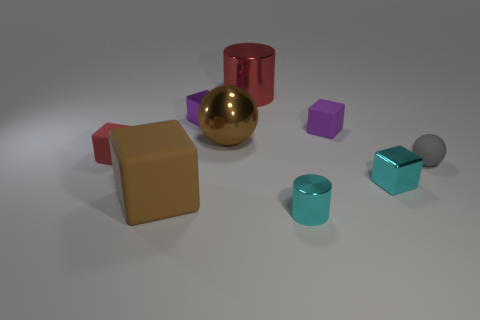There is a metal thing that is the same color as the big cube; what shape is it?
Ensure brevity in your answer.  Sphere. There is a purple rubber cube; does it have the same size as the cylinder behind the big brown shiny ball?
Offer a very short reply. No. There is a brown thing on the right side of the large rubber block; what material is it?
Provide a short and direct response. Metal. There is a tiny cyan thing that is in front of the cyan shiny block; what number of cyan metallic things are behind it?
Provide a succinct answer. 1. Are there any other small rubber objects of the same shape as the gray matte thing?
Give a very brief answer. No. Does the brown object that is right of the tiny purple metallic cube have the same size as the purple rubber object right of the big brown rubber thing?
Ensure brevity in your answer.  No. There is a brown object behind the metal cube that is in front of the tiny purple shiny thing; what is its shape?
Offer a very short reply. Sphere. What number of purple metallic objects are the same size as the red cylinder?
Your answer should be compact. 0. Are any small red matte cylinders visible?
Provide a succinct answer. No. Is there any other thing of the same color as the tiny metallic cylinder?
Offer a very short reply. Yes. 